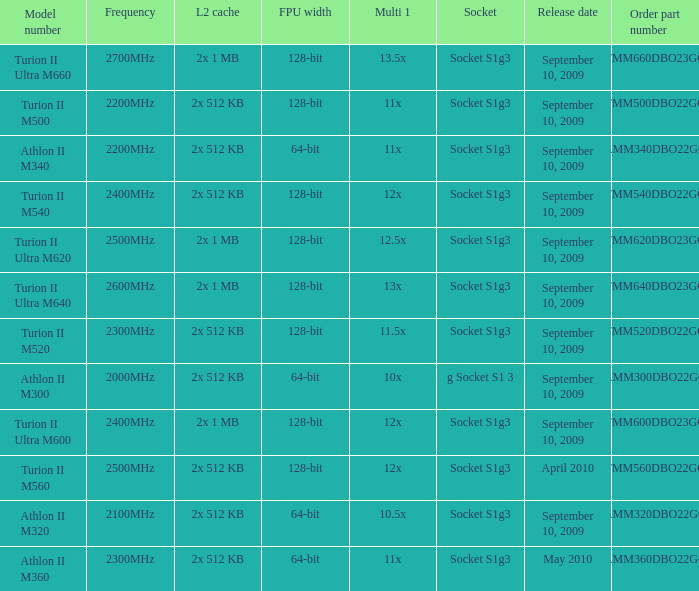What is the L2 cache with a 13.5x multi 1? 2x 1 MB. 